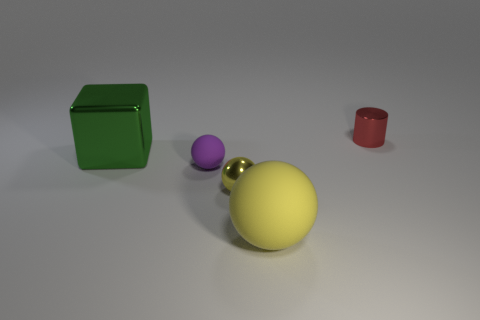Add 3 red matte balls. How many objects exist? 8 Subtract all yellow balls. How many balls are left? 1 Subtract 1 cylinders. How many cylinders are left? 0 Subtract all tiny yellow shiny spheres. How many spheres are left? 2 Subtract all cyan blocks. Subtract all cyan cylinders. How many blocks are left? 1 Subtract all purple cylinders. How many yellow spheres are left? 2 Subtract all cubes. Subtract all large metallic objects. How many objects are left? 3 Add 5 tiny cylinders. How many tiny cylinders are left? 6 Add 1 small yellow shiny cylinders. How many small yellow shiny cylinders exist? 1 Subtract 0 green cylinders. How many objects are left? 5 